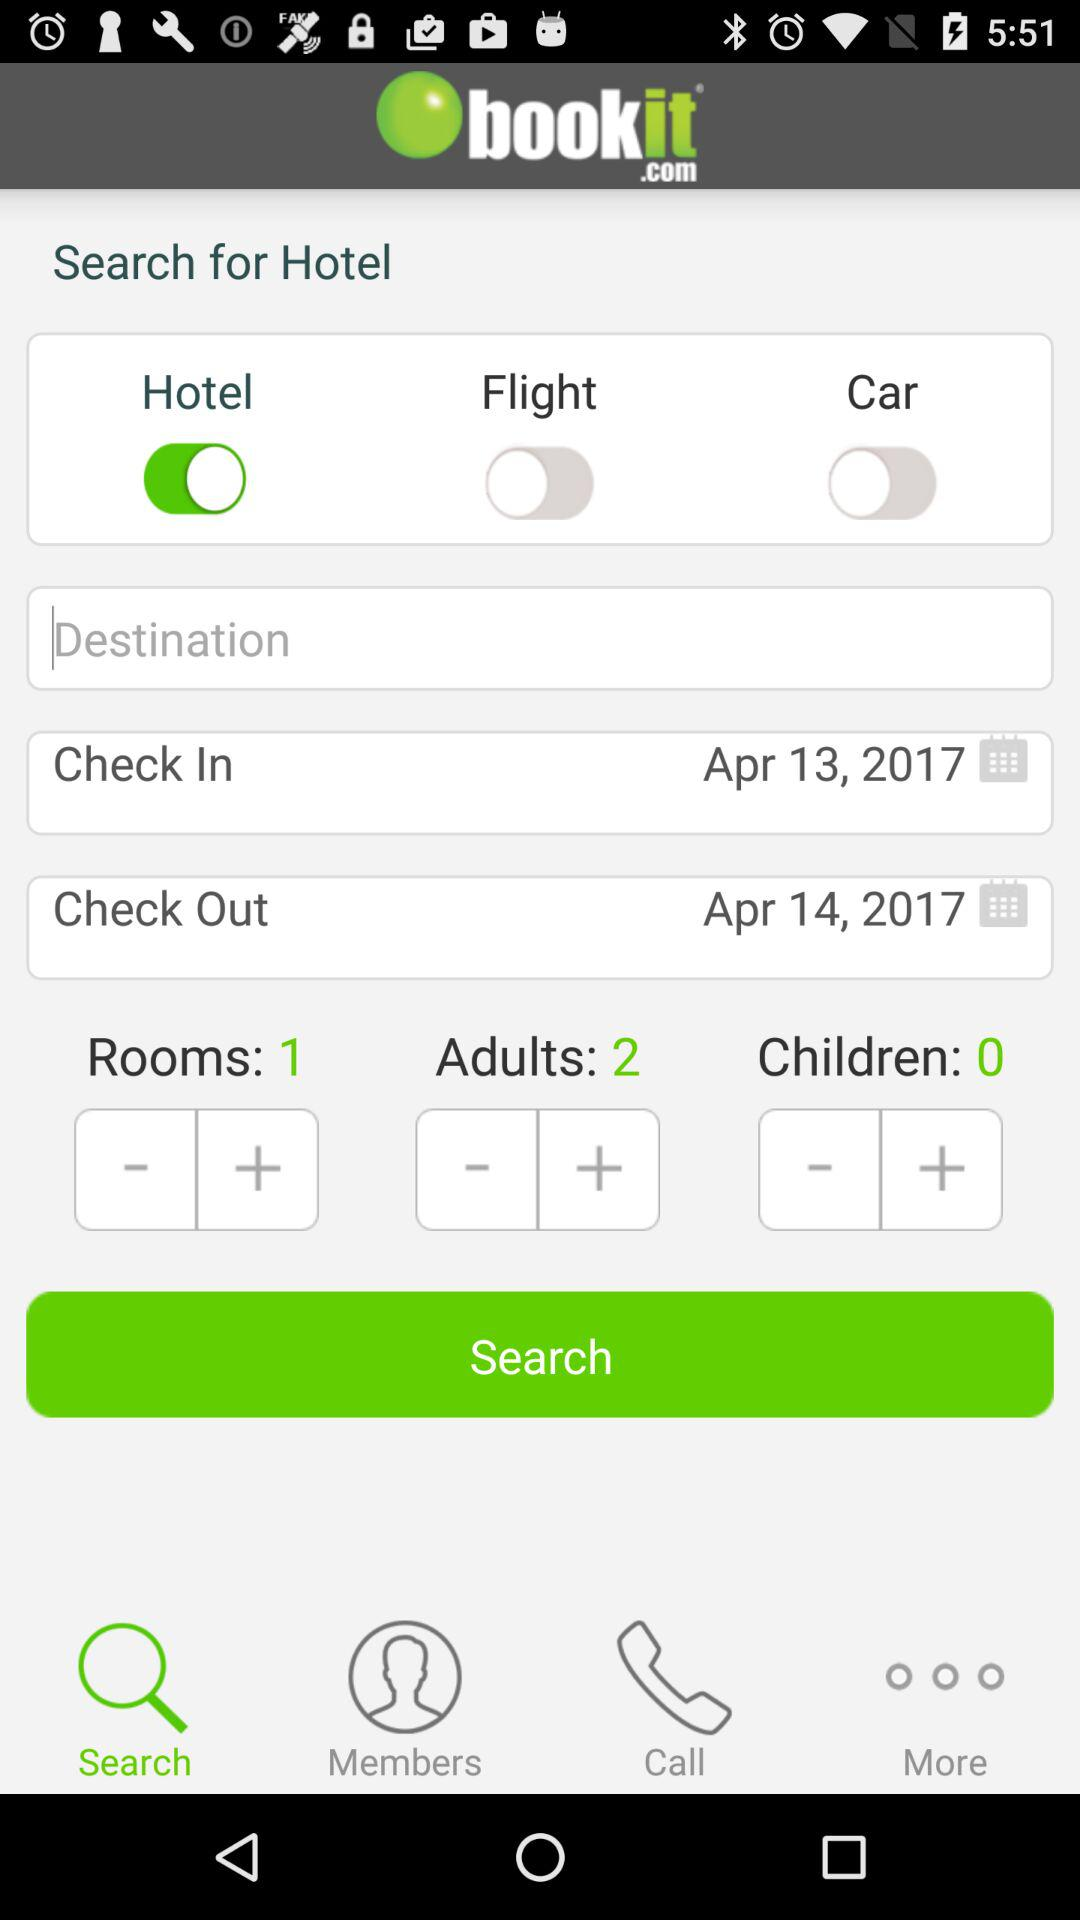How many days are between the check in and check out dates?
Answer the question using a single word or phrase. 1 